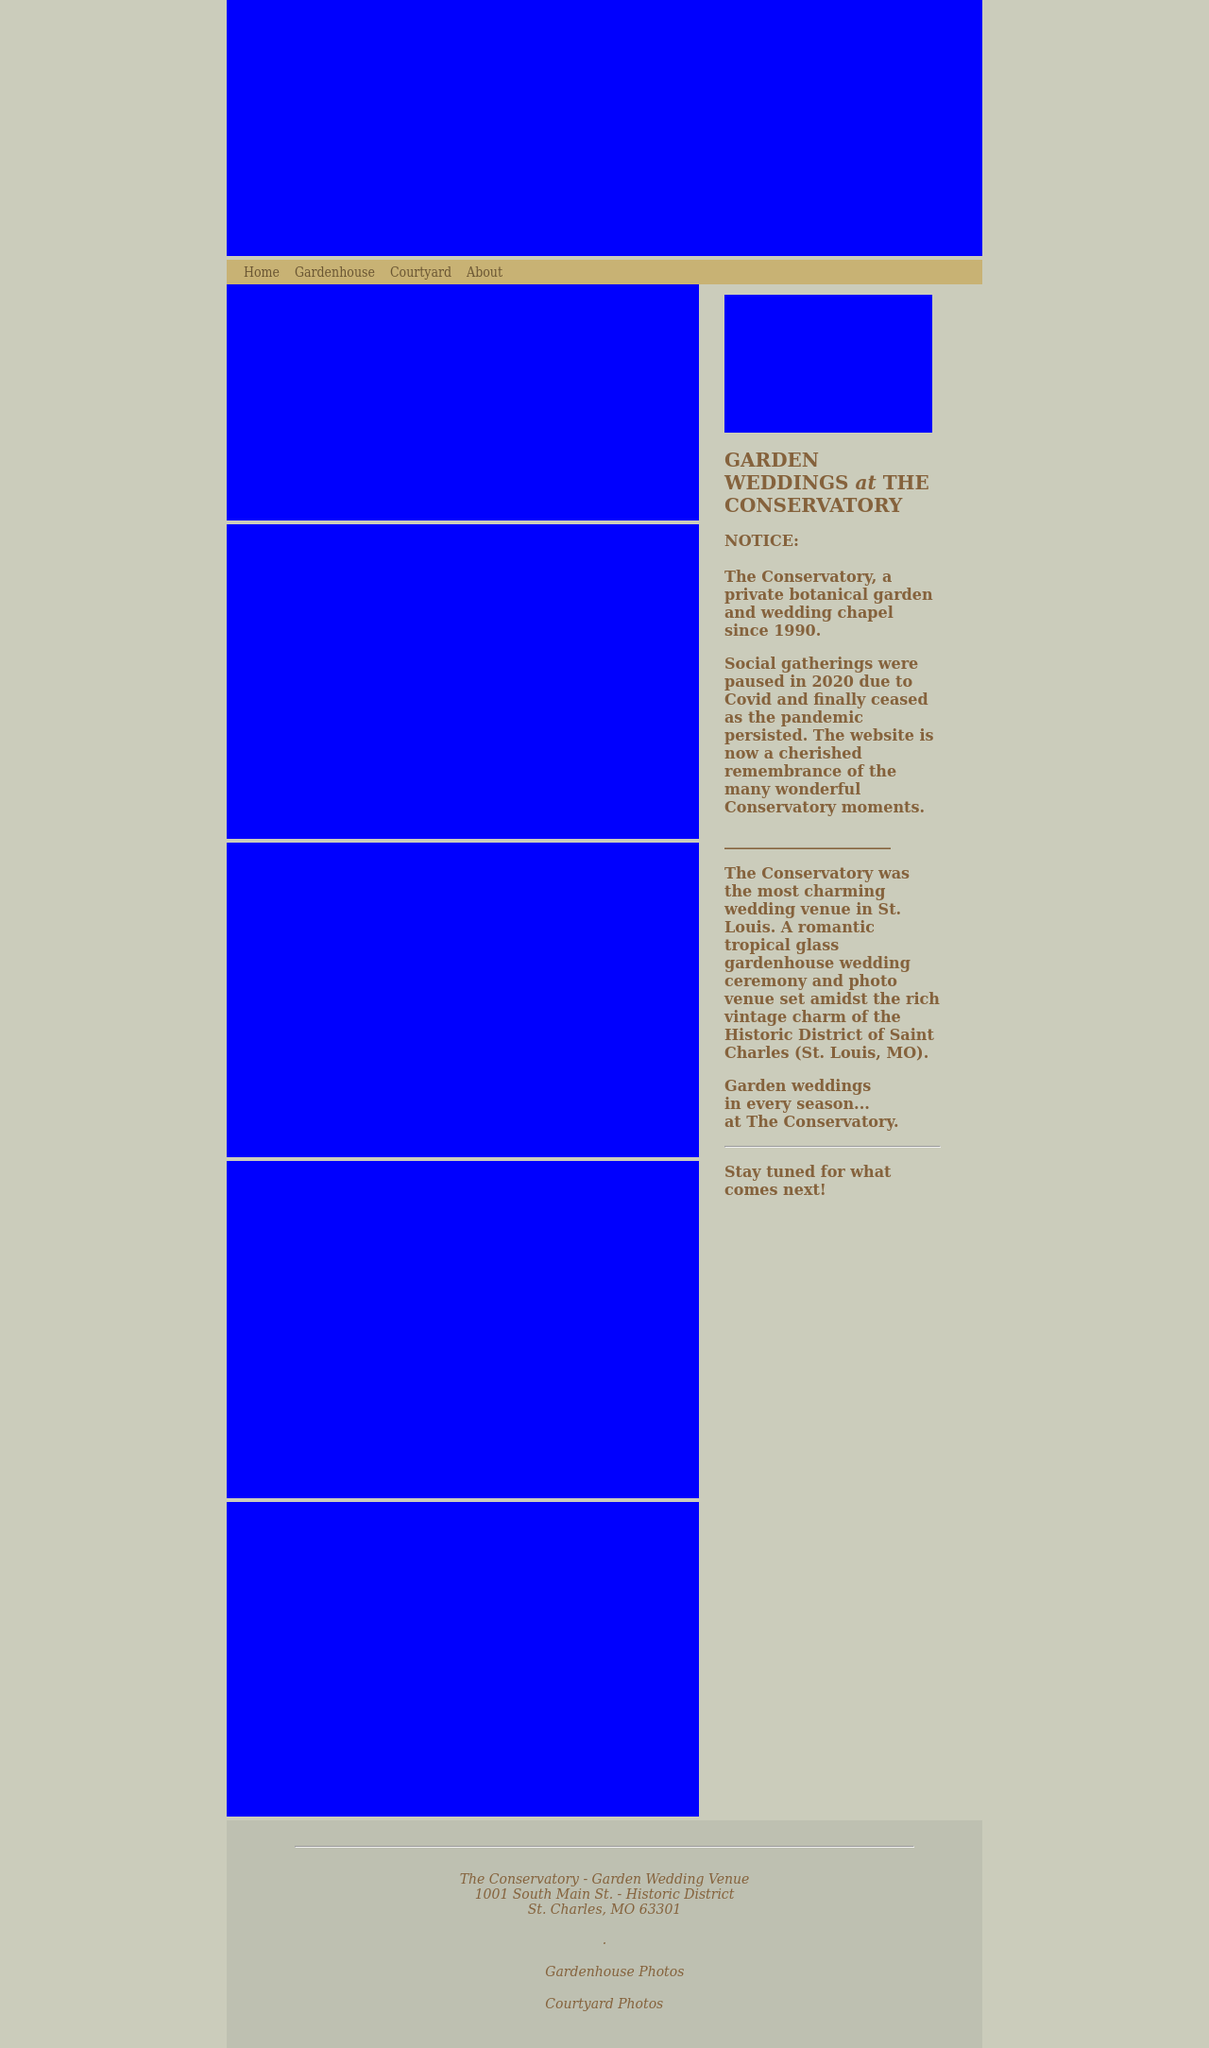What types of plants and flowers are typically included in the garden spaces for weddings at this venue? The Conservatory often includes a variety of flowering plants and lush greenery to create a romantic and enchanting garden atmosphere. Common choices include roses, hydrangeas, and peonies, along with various evergreens and ferns to add to the verdant ambiance. How is the garden maintained to ensure it remains picturesque throughout the year? The garden is meticulously maintained by a dedicated team of horticulturists who regularly tend to the plantings, ensuring they are healthy, vibrant, and well-groomed. Seasonal plantings are carefully planned to ensure that the garden remains colorful and inviting in every season. 